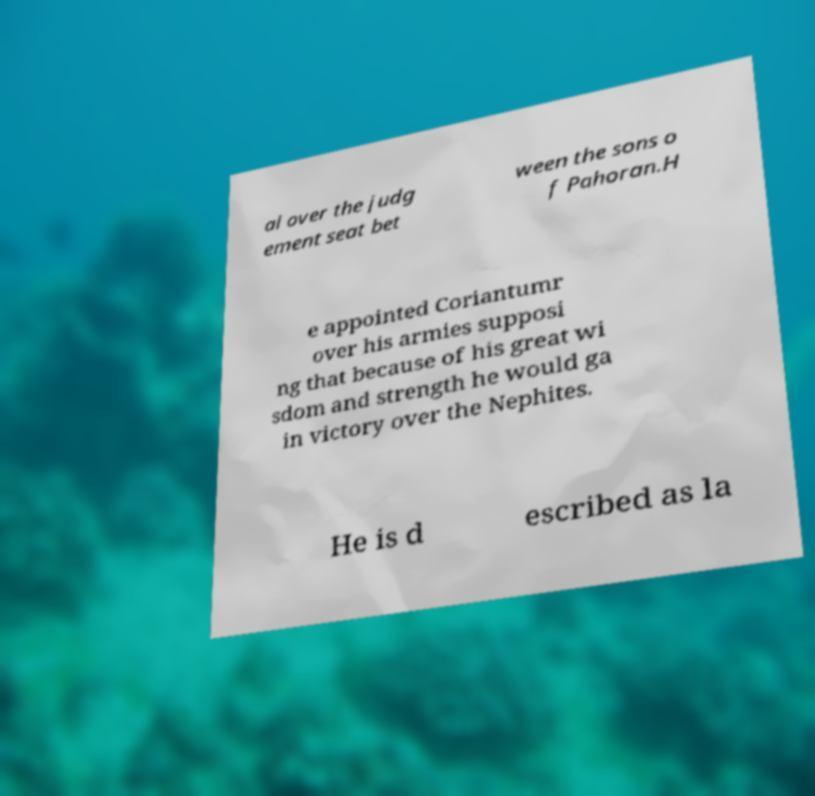Please identify and transcribe the text found in this image. al over the judg ement seat bet ween the sons o f Pahoran.H e appointed Coriantumr over his armies supposi ng that because of his great wi sdom and strength he would ga in victory over the Nephites. He is d escribed as la 